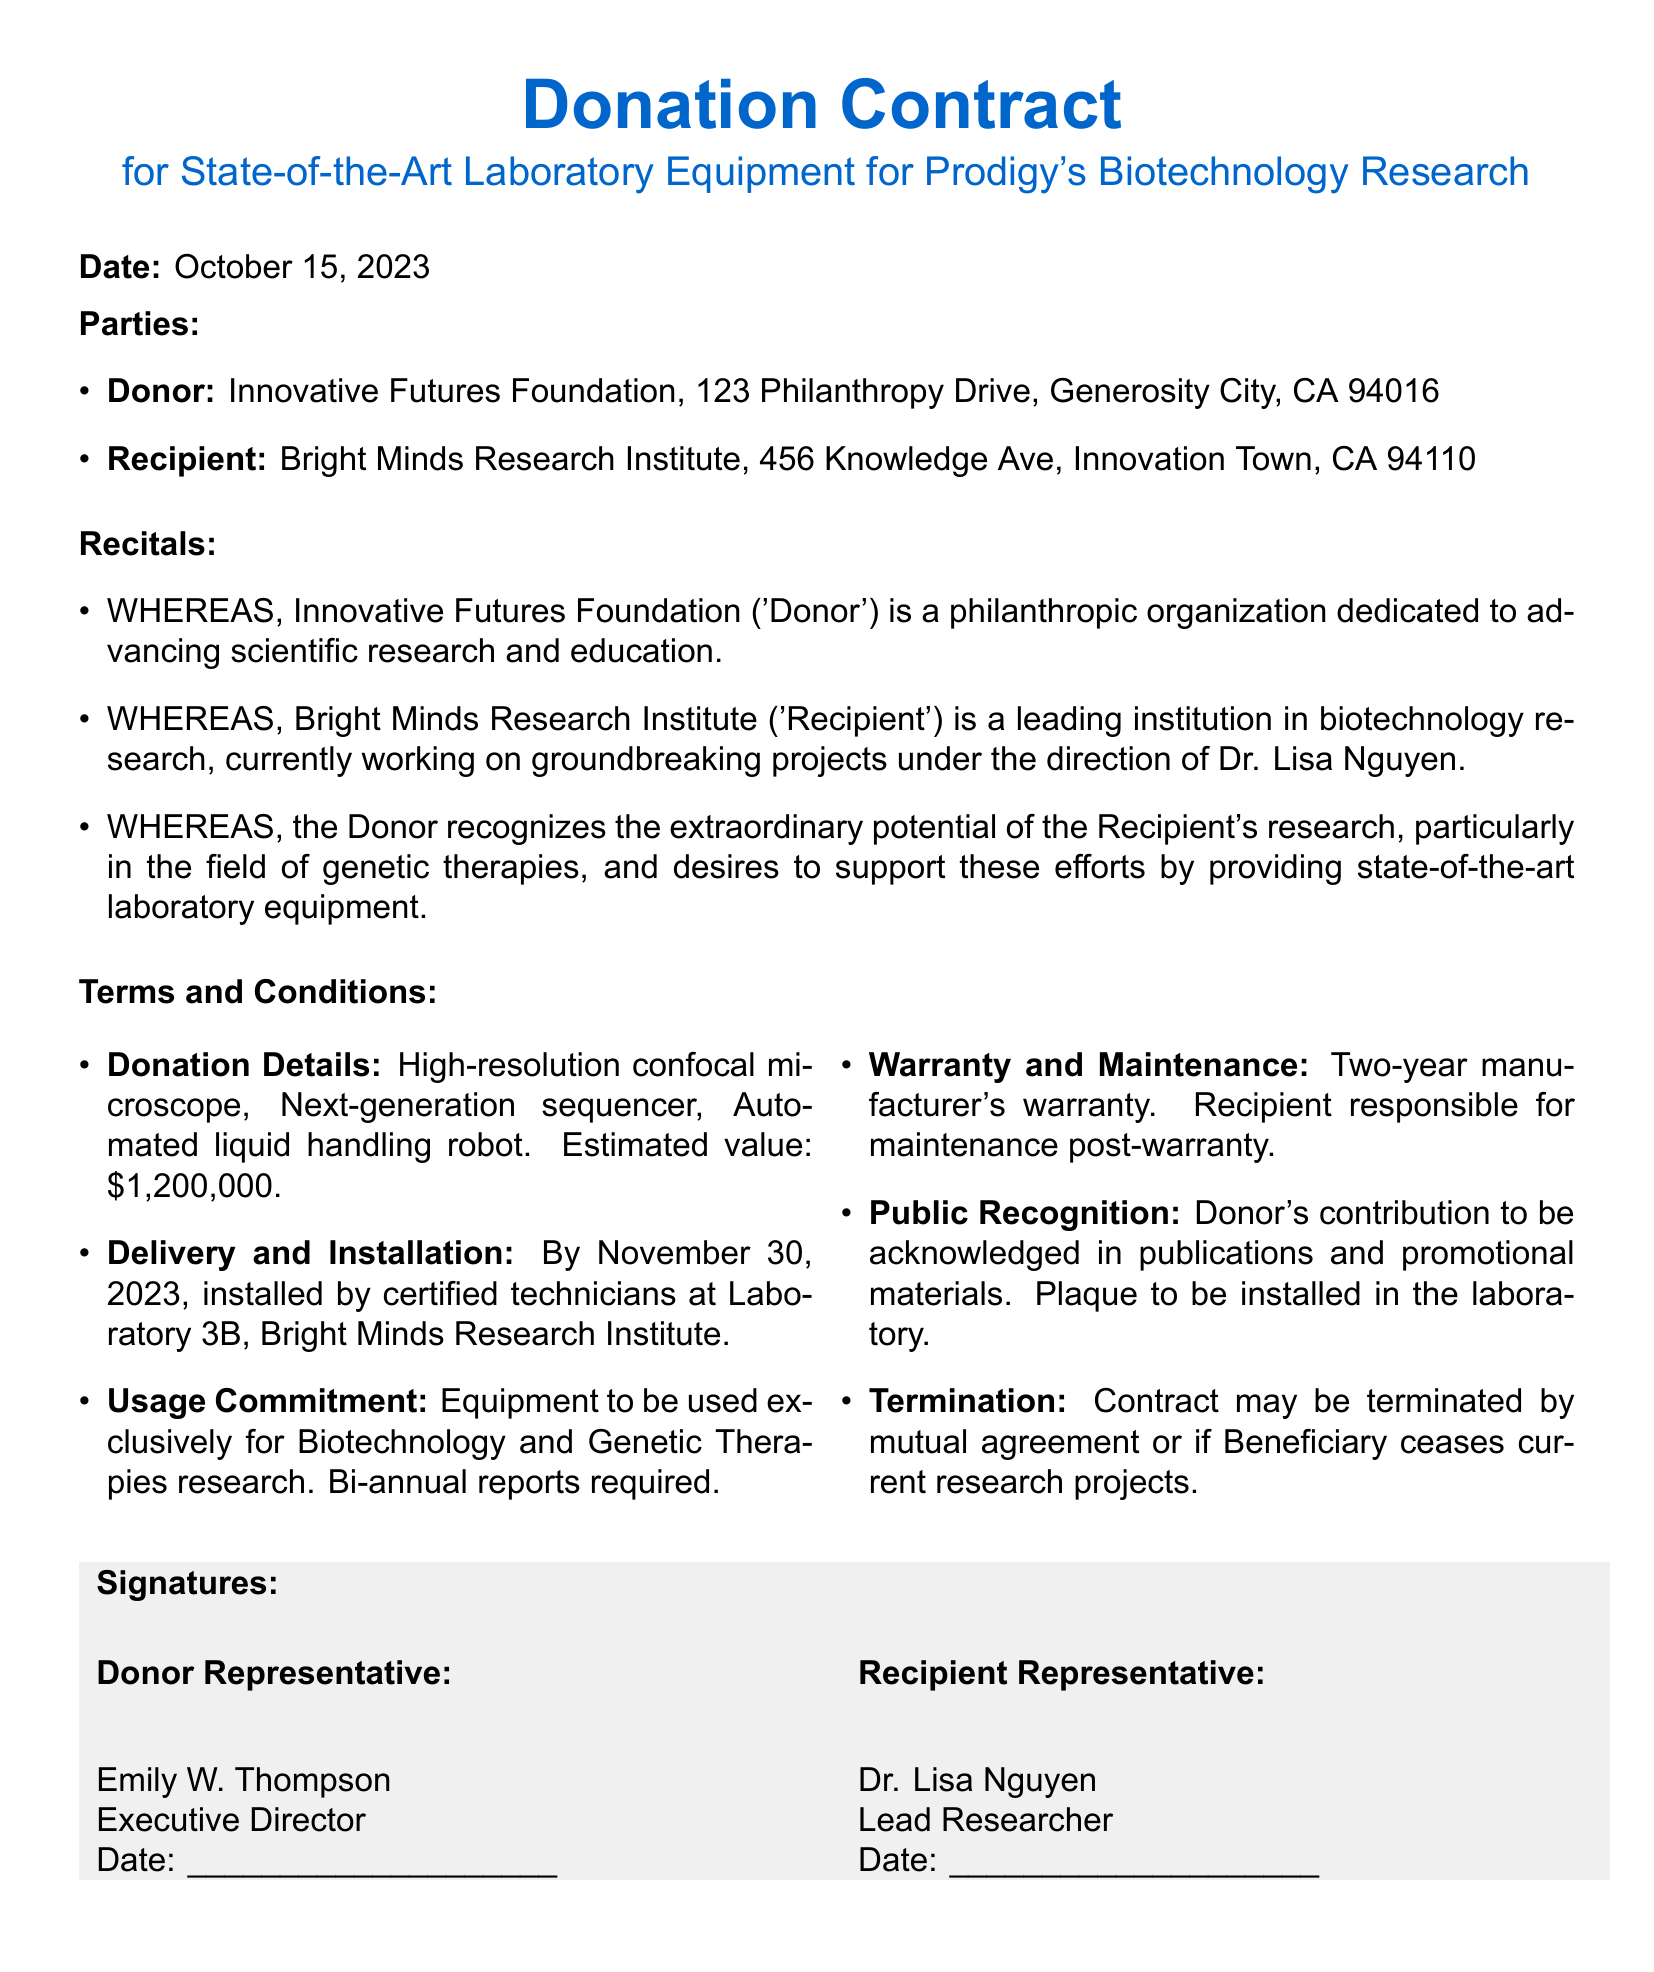What is the date of the contract? The date is specified at the beginning of the document.
Answer: October 15, 2023 Who is the donor organization? The document lists the donor organization in the "Parties" section.
Answer: Innovative Futures Foundation What is the estimated value of the donation? The estimated value is mentioned in the "Terms and Conditions" section.
Answer: $1,200,000 What equipment is being donated? The types of equipment are listed in the "Donation Details" subsection.
Answer: High-resolution confocal microscope, Next-generation sequencer, Automated liquid handling robot By when should the equipment be delivered and installed? The deadline for delivery and installation is given in "Delivery and Installation."
Answer: November 30, 2023 What is required from the recipient regarding the usage of the equipment? The requirements for usage are stated in the "Usage Commitment" section.
Answer: Bi-annual reports required Who is the recipient representative? The name of the recipient representative is provided in the "Signatures" section.
Answer: Dr. Lisa Nguyen What is the warranty period for the equipment? The warranty period is specified in the "Warranty and Maintenance" section.
Answer: Two years What can lead to the termination of the contract? The reasons for termination are discussed in the "Termination" section.
Answer: Mutual agreement or if Beneficiary ceases current research projects 